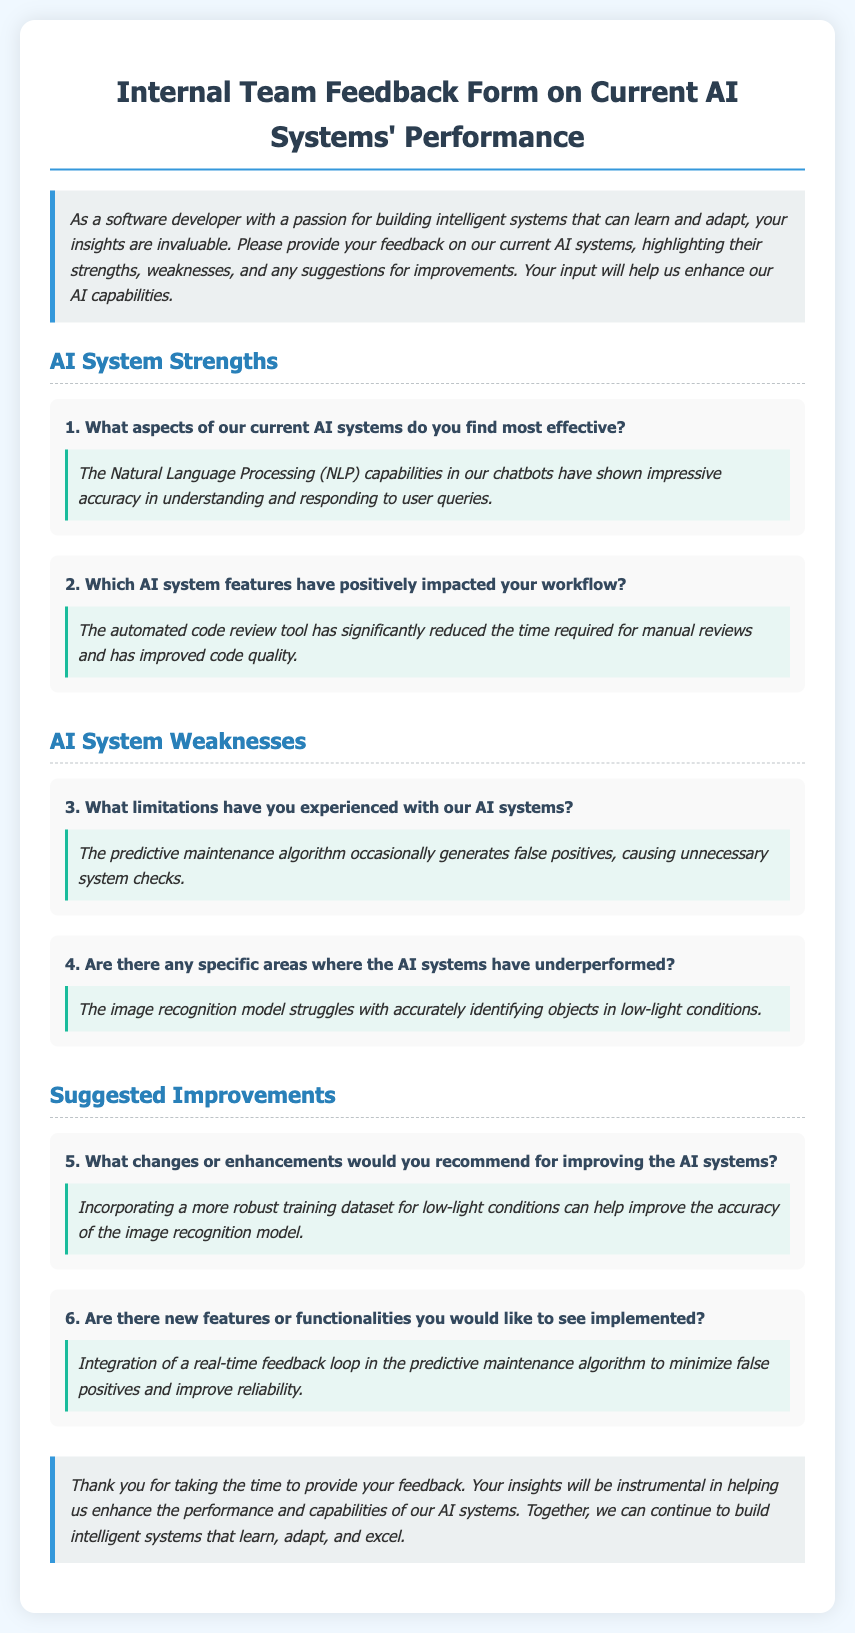What aspects of the AI systems are highlighted as strengths? The strengths section describes effective aspects of the AI systems, specifically mentioning the Natural Language Processing capabilities in chatbots.
Answer: Natural Language Processing (NLP) What feature of the AI systems has improved code quality? The response to the AI system features question specifies that the automated code review tool has positively impacted workflow by improving code quality.
Answer: Automated code review tool What limitation is mentioned regarding the predictive maintenance algorithm? The weaknesses section indicates that the predictive maintenance algorithm generates false positives.
Answer: False positives In which conditions does the image recognition model struggle? The weaknesses section provides information that the image recognition model struggles with low-light conditions.
Answer: Low-light conditions What is suggested to enhance the image recognition model's accuracy? The suggested improvements include incorporating a more robust training dataset for low-light conditions.
Answer: More robust training dataset What new feature is desired for the predictive maintenance algorithm? The response mentions a desire for integration of a real-time feedback loop in the predictive maintenance algorithm.
Answer: Real-time feedback loop How many strengths questions are included in the document? Counting the number of strengths-related questions in the strengths section, there are two questions listed.
Answer: Two What color is used for the section titles in the document? The visual style specifies that section titles are colored with a specific color code, which is a shade of blue.
Answer: Blue What should the feedback help enhance? The conclusion indicates that the feedback will help enhance the performance and capabilities of the AI systems.
Answer: Performance and capabilities 